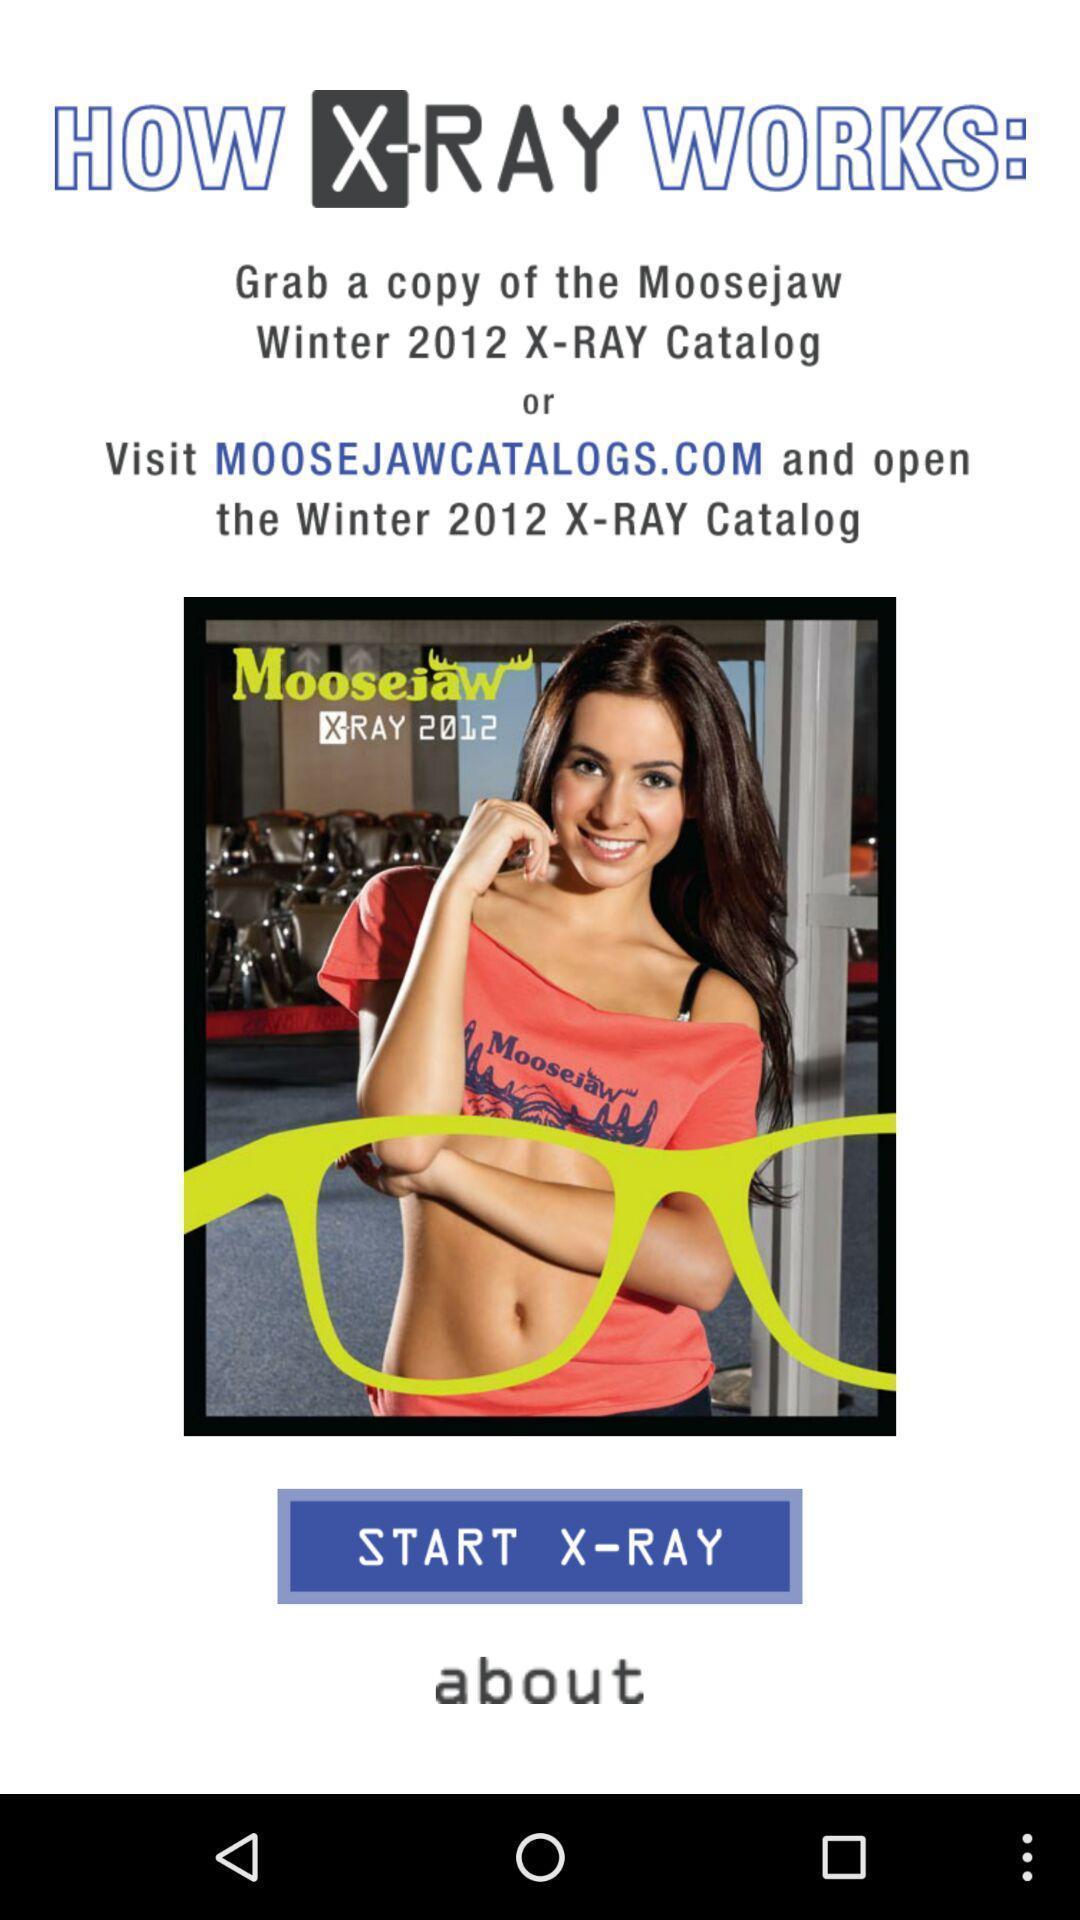Give me a narrative description of this picture. Welcome page displayed to start. 